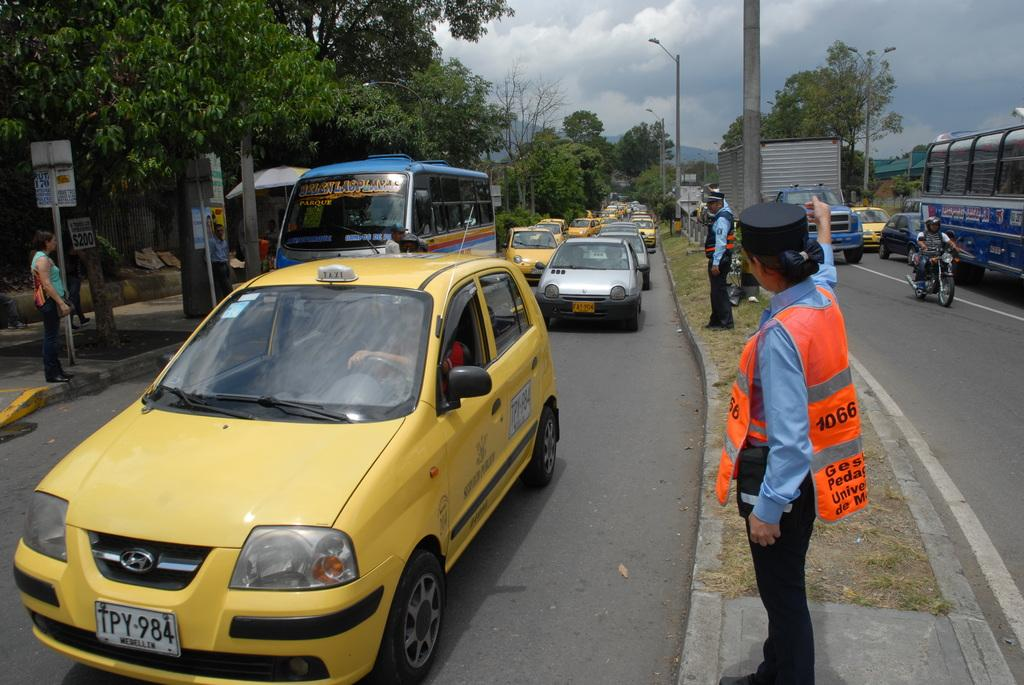<image>
Give a short and clear explanation of the subsequent image. A police officer directs a yellow taxi with the license plate TPY-984. 